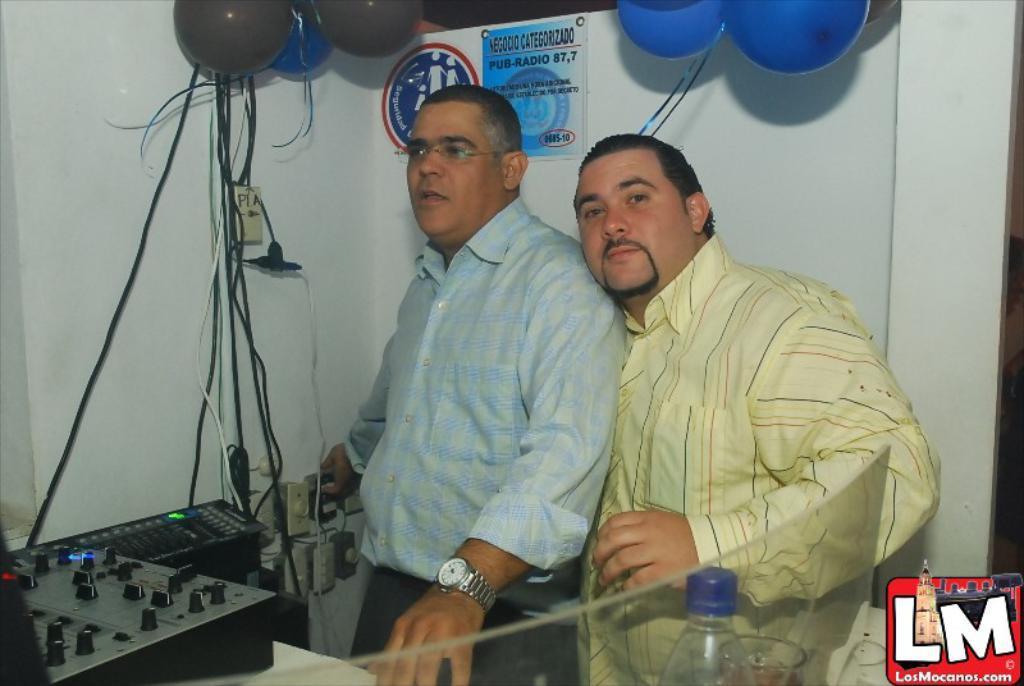Could you give a brief overview of what you see in this image? In this image we can see two men are standing. One is wearing blue color shirt and the other one is wearing yellow color shirt. In front of them black color controller machine is there. And behind them white color wall and blue and black color balloons are there. On wall two posts are posted. Bottom of the image bottle and glass is present. 